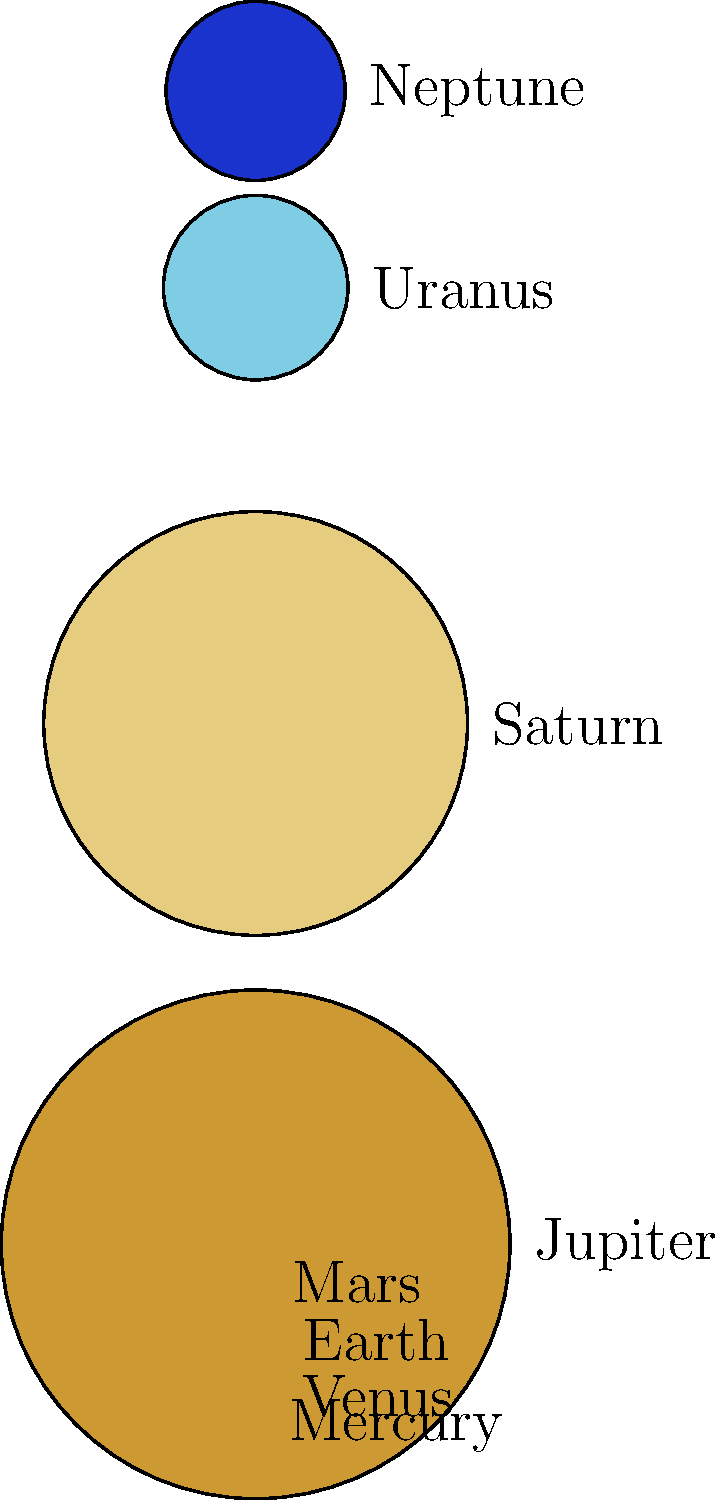In our exploration of the cosmos, we often encounter the vastness of creation. Looking at the diagram of our solar system's planets, which shows their relative sizes, what spiritual insight might we draw about the diversity and inclusivity of God's universe? How does this relate to our calling as a progressive Armenian church to embrace diversity in our community? To answer this question, let's consider the following steps:

1. Observe the diversity in planet sizes:
   - The diagram shows a wide range of planet sizes, from the smallest (Mercury) to the largest (Jupiter).
   - There's no single "standard" size for planets; each is unique.

2. Reflect on the order and harmony:
   - Despite their differences, all planets coexist in the same solar system.
   - Each planet, regardless of size, plays a crucial role in the system's balance.

3. Consider the spiritual implications:
   - The diversity in planet sizes can be seen as a reflection of God's creativity and love for variety.
   - Just as each planet has its place, every individual in our church community is valuable, regardless of differences.

4. Apply to church inclusivity:
   - Like the solar system, our church can embrace diversity (in age, background, perspective) while maintaining unity.
   - As a progressive Armenian church, we're called to recognize and celebrate the unique "size" or role of each member.

5. Connect to theological concepts:
   - In 1 Corinthians 12:12-27, Paul compares the church to a body with diverse parts, each essential.
   - This astronomical view reinforces the idea of unity in diversity within God's creation and our church.

6. Practical application:
   - This insight can inspire us to create inclusive programs and ministries that cater to diverse needs within our community.
   - It encourages us to value and amplify diverse voices in our church leadership and decision-making processes.
Answer: The diverse planet sizes reflect God's love for variety, inspiring our church to embrace and celebrate the uniqueness of each member, fostering an inclusive community that values all contributions. 